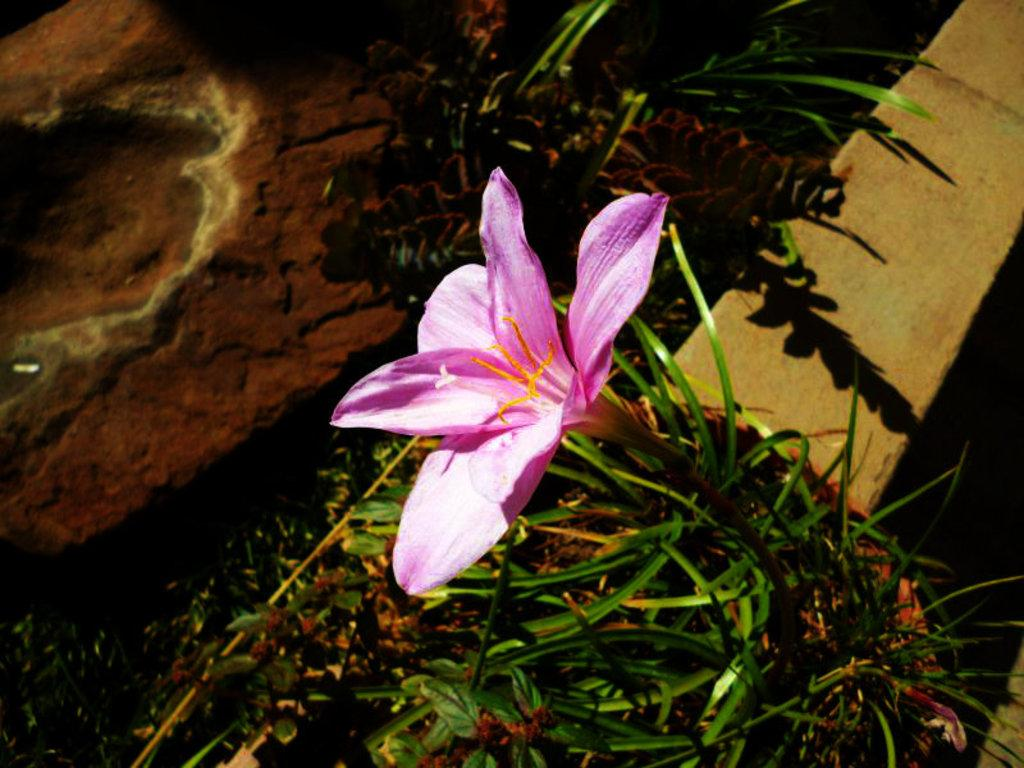What type of plant is visible in the image? There is a house plant with a flower in the image. Where is the house plant located? The house plant is placed on a wall. What else can be seen near the wall in the image? There is a brick beside the wall in the image. What type of jeans is the pump wearing in the image? There are no jeans or pumps present in the image; it features a house plant with a flower on a wall and a brick beside the wall. 